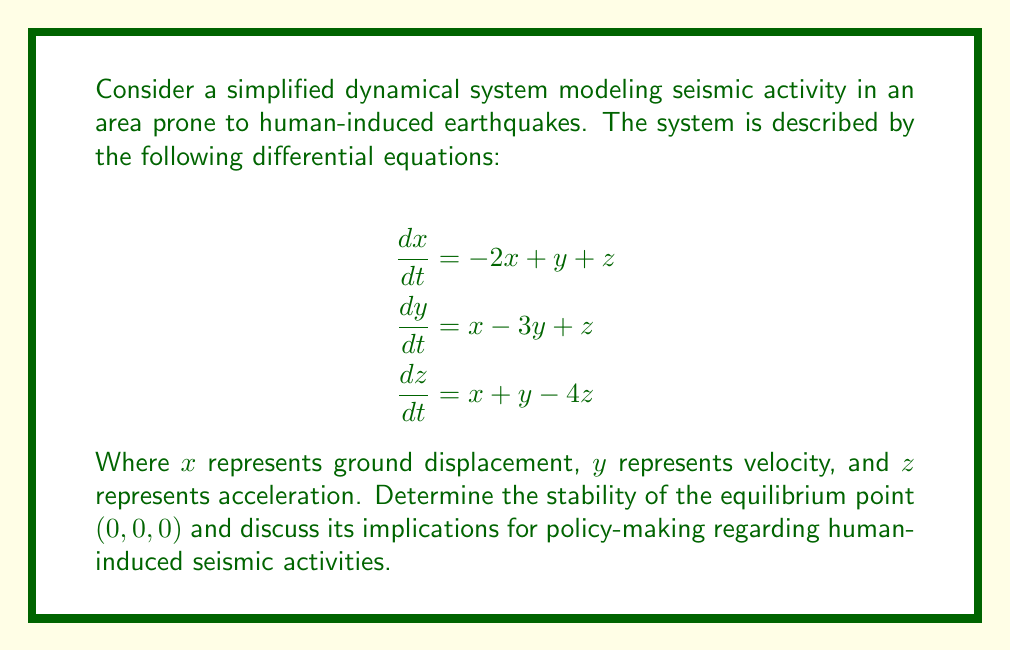What is the answer to this math problem? To analyze the stability of the equilibrium point $(0,0,0)$, we need to follow these steps:

1) First, we write the system in matrix form:

   $$\frac{d}{dt}\begin{bmatrix}x \\ y \\ z\end{bmatrix} = \begin{bmatrix}-2 & 1 & 1 \\ 1 & -3 & 1 \\ 1 & 1 & -4\end{bmatrix}\begin{bmatrix}x \\ y \\ z\end{bmatrix}$$

2) The stability of the equilibrium point is determined by the eigenvalues of the coefficient matrix A:

   $$A = \begin{bmatrix}-2 & 1 & 1 \\ 1 & -3 & 1 \\ 1 & 1 & -4\end{bmatrix}$$

3) To find the eigenvalues, we solve the characteristic equation:

   $$det(A - \lambda I) = 0$$

   $$\begin{vmatrix}-2-\lambda & 1 & 1 \\ 1 & -3-\lambda & 1 \\ 1 & 1 & -4-\lambda\end{vmatrix} = 0$$

4) Expanding this determinant:

   $$-(\lambda+2)(\lambda+3)(\lambda+4) + 1 + 1 + 1 - (\lambda+2) - (\lambda+3) - (\lambda+4) = 0$$

   $$-\lambda^3 - 9\lambda^2 - 26\lambda - 24 + 3 - 3\lambda - 9 = 0$$

   $$-\lambda^3 - 9\lambda^2 - 29\lambda - 30 = 0$$

5) Solving this equation (which can be done numerically), we get the eigenvalues:

   $$\lambda_1 \approx -6.3230, \lambda_2 \approx -1.8385, \lambda_3 \approx -0.8385$$

6) Since all eigenvalues are real and negative, the equilibrium point $(0,0,0)$ is asymptotically stable.

This stability implies that small perturbations in the system (such as minor seismic activities) will naturally decay over time, returning the system to its equilibrium state. For policy-making, this suggests that minor human-induced seismic activities might not lead to catastrophic outcomes, as the system tends to stabilize itself. However, large perturbations could still potentially push the system beyond its stable regime, so regulations should still aim to minimize significant human-induced seismic activities.
Answer: Asymptotically stable 